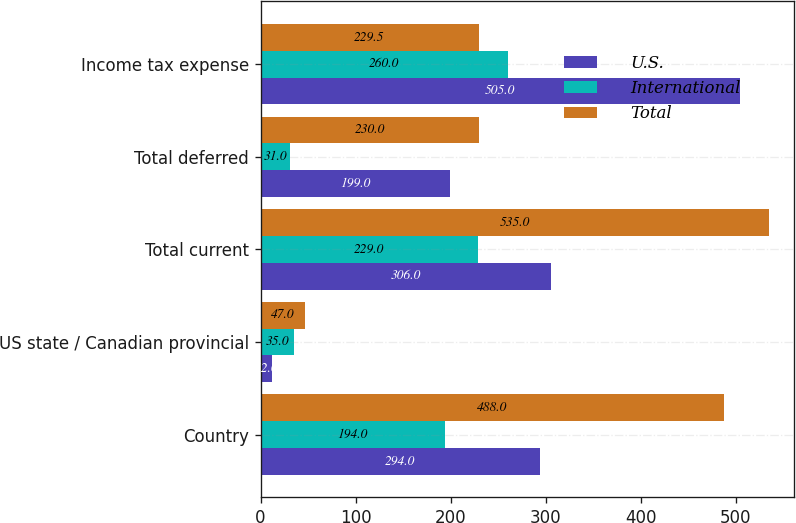Convert chart to OTSL. <chart><loc_0><loc_0><loc_500><loc_500><stacked_bar_chart><ecel><fcel>Country<fcel>US state / Canadian provincial<fcel>Total current<fcel>Total deferred<fcel>Income tax expense<nl><fcel>U.S.<fcel>294<fcel>12<fcel>306<fcel>199<fcel>505<nl><fcel>International<fcel>194<fcel>35<fcel>229<fcel>31<fcel>260<nl><fcel>Total<fcel>488<fcel>47<fcel>535<fcel>230<fcel>229.5<nl></chart> 